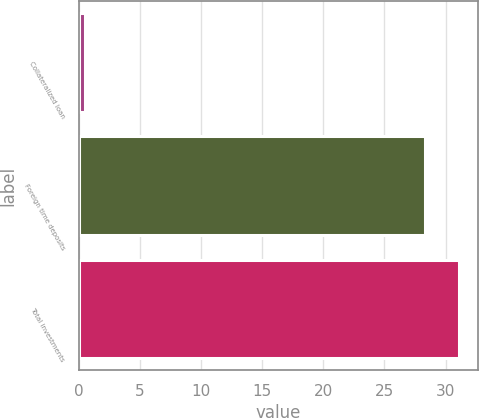Convert chart to OTSL. <chart><loc_0><loc_0><loc_500><loc_500><bar_chart><fcel>Collateralized loan<fcel>Foreign time deposits<fcel>Total investments<nl><fcel>0.5<fcel>28.3<fcel>31.08<nl></chart> 